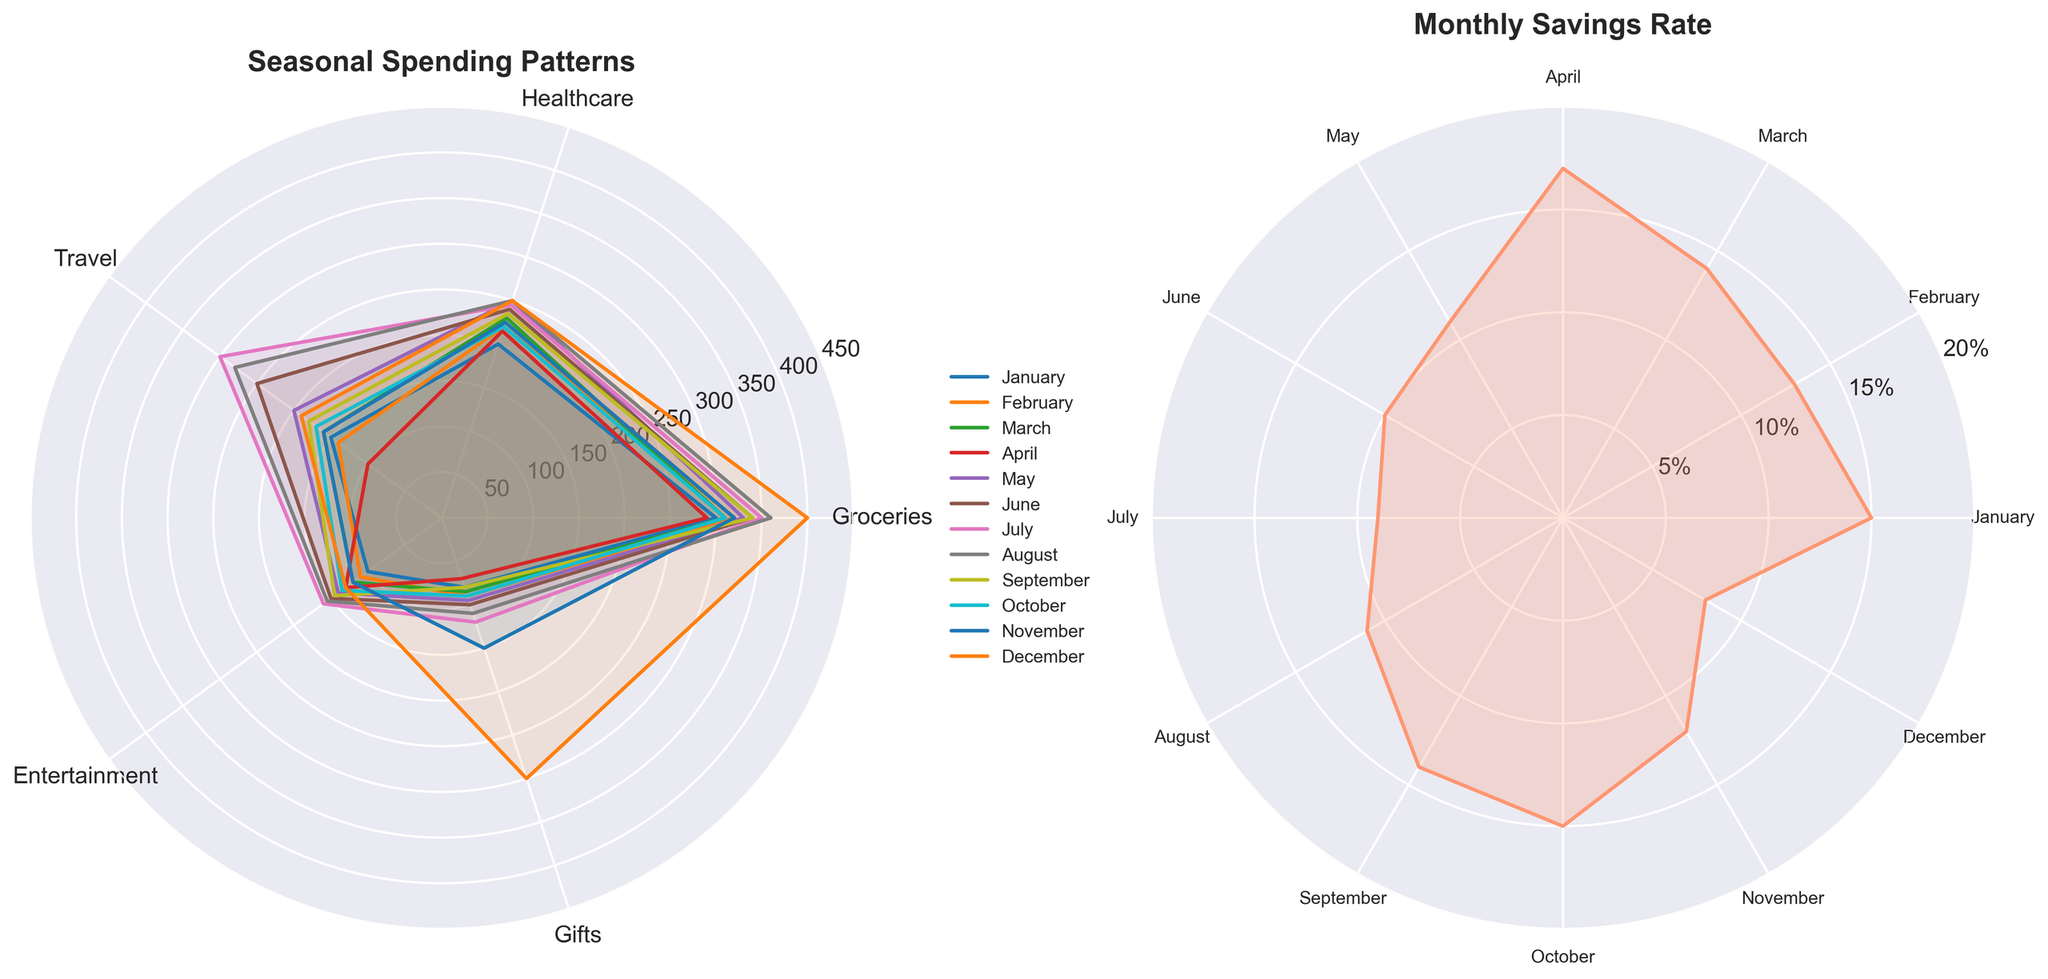What are the titles of the two subplots? The titles of the two subplots can be directly read from the figure. The left subplot is titled "Seasonal Spending Patterns" and the right subplot is titled "Monthly Savings Rate".
Answer: Seasonal Spending Patterns and Monthly Savings Rate Which month has the highest spending on Groceries? To find this, we observe the radial distance of the lines representing each month on the groceries axis of the left subplot. The longest line corresponds to the highest spending. December has the highest spending on Groceries at a value of 400.
Answer: December How does the savings rate trend from January to December? We follow the line in the right subplot, noting the changes month by month. Generally, the savings rate decreases from January (0.15) to December (0.08).
Answer: Decreases Which category has the most consistent spending across all months? By comparing the shapes of the plotted lines across the five categories in the left subplot, Healthcare appears to have the least variation in spending, indicating consistency.
Answer: Healthcare What is the difference in spending on Travel between June and September? On the left subplot, observe the radial distance for Travel in both June and September. June has a distance of 250, and September has a distance of 180. The difference is 250 - 180 = 70.
Answer: 70 In which month is the savings rate the lowest, and what is its value? By observing the minimum point on the right subplot, the lowest savings rate occurs in December with a value of 0.08.
Answer: December, 0.08 Compare the spending on Entertainment in July and August. Which month is higher and by how much? Observing the Entertainment axis in the left subplot, July has a value of 160 while August has a value of 155. The difference is 160 - 155 = 5, so July is higher by 5 units.
Answer: July, 5 Which spending category has the largest difference between its highest and lowest spending months? Visually comparing the range covered by each category in the left subplot, Groceries has the largest difference, with the highest in December (400) and the lowest in April (290). The difference is 400 - 290 = 110.
Answer: Groceries What is the average savings rate over the year? The savings rates for each month are summed (0.15 + 0.13 + 0.14 + 0.17 + 0.11 + 0.10 + 0.09 + 0.11 + 0.14 + 0.15 + 0.12 + 0.08 = 1.49). The average is 1.49 divided by 12 months, giving 0.1242.
Answer: 0.1242 How does the spending on Gifts change from October to December? Observing the Gifts axis in the left subplot, spending increases from October (90) to November (150), and then to December (300).
Answer: Increases 